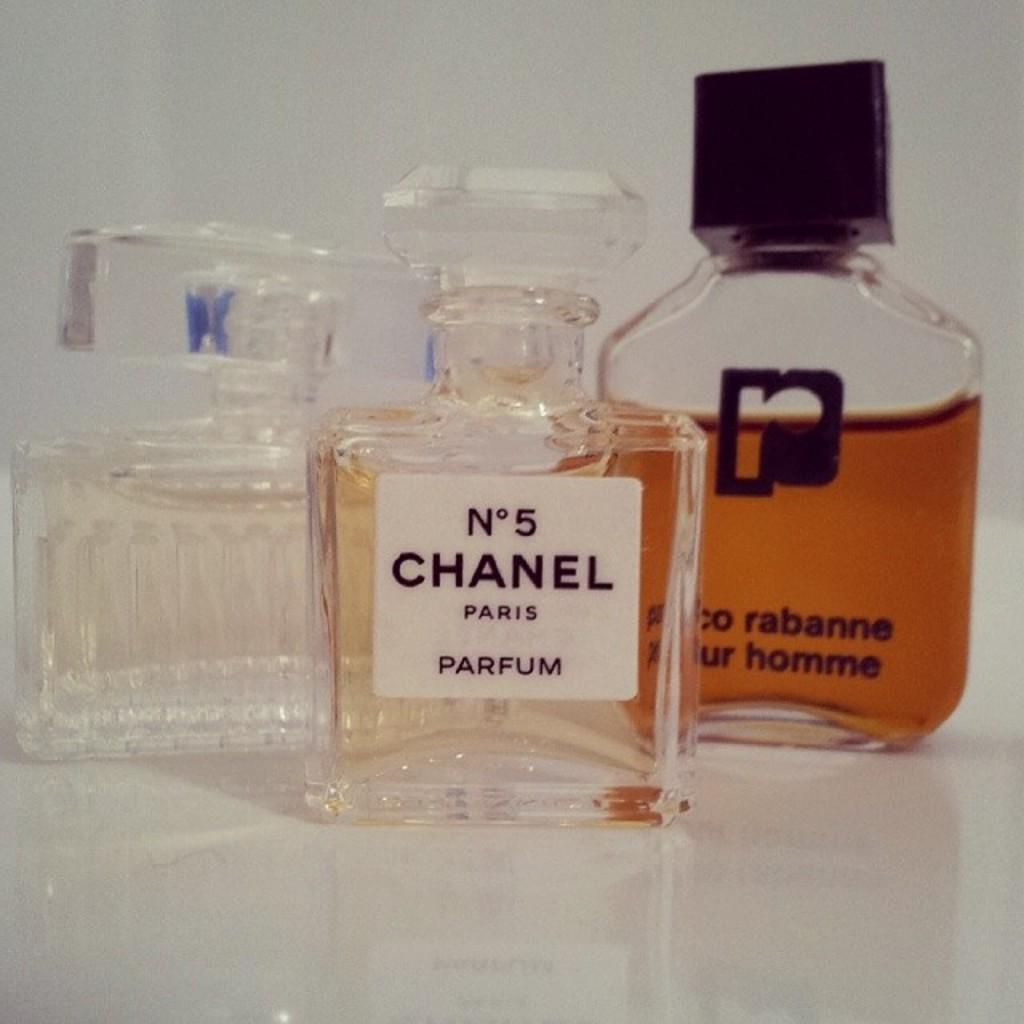<image>
Give a short and clear explanation of the subsequent image. The famous Chanel No5 sits in the middle of three perfumes. 